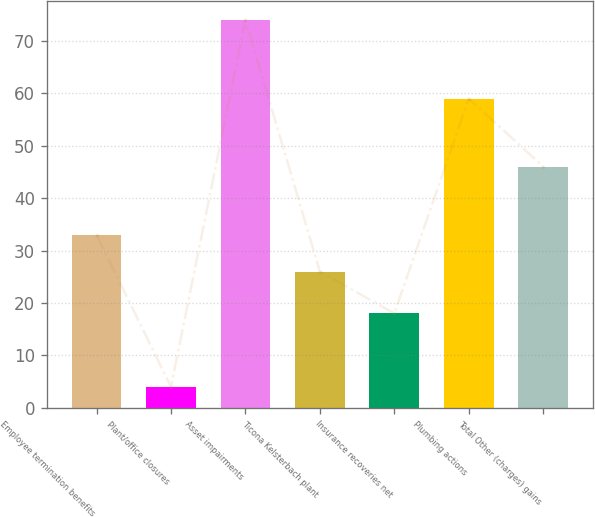<chart> <loc_0><loc_0><loc_500><loc_500><bar_chart><fcel>Employee termination benefits<fcel>Plant/office closures<fcel>Asset impairments<fcel>Ticona Kelsterbach plant<fcel>Insurance recoveries net<fcel>Plumbing actions<fcel>Total Other (charges) gains<nl><fcel>33<fcel>4<fcel>74<fcel>26<fcel>18<fcel>59<fcel>46<nl></chart> 